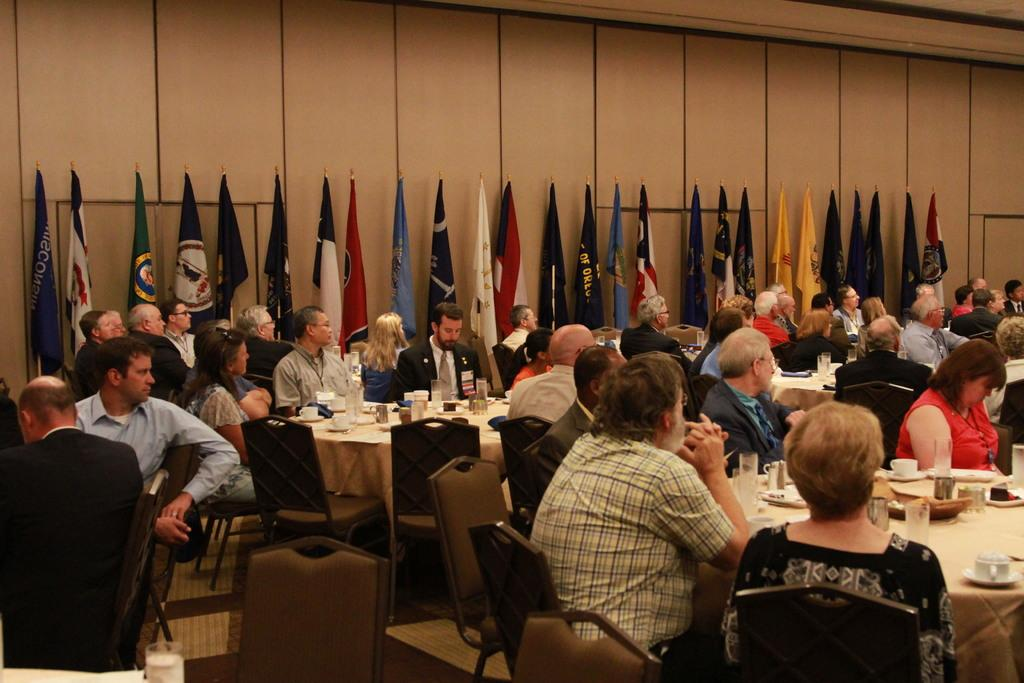What are the people in the image doing? The people in the image are sitting on chairs. What objects are in front of the people? There are tables in front of the people. What items can be seen on the tables? There are glasses, cups, and saucers on the tables. Are there any other elements in the image? Yes, there are flags in the image. Can you describe the maid in the image? There is no maid present in the image. What type of building is depicted in the image? The image does not show any building; it only features people sitting on chairs, tables, and flags. 